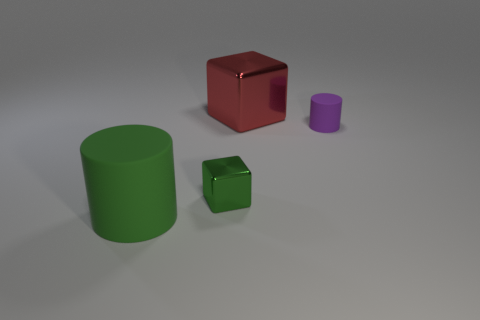Add 4 red shiny blocks. How many objects exist? 8 Subtract all big brown balls. Subtract all tiny green objects. How many objects are left? 3 Add 2 purple rubber cylinders. How many purple rubber cylinders are left? 3 Add 1 tiny gray spheres. How many tiny gray spheres exist? 1 Subtract 0 purple balls. How many objects are left? 4 